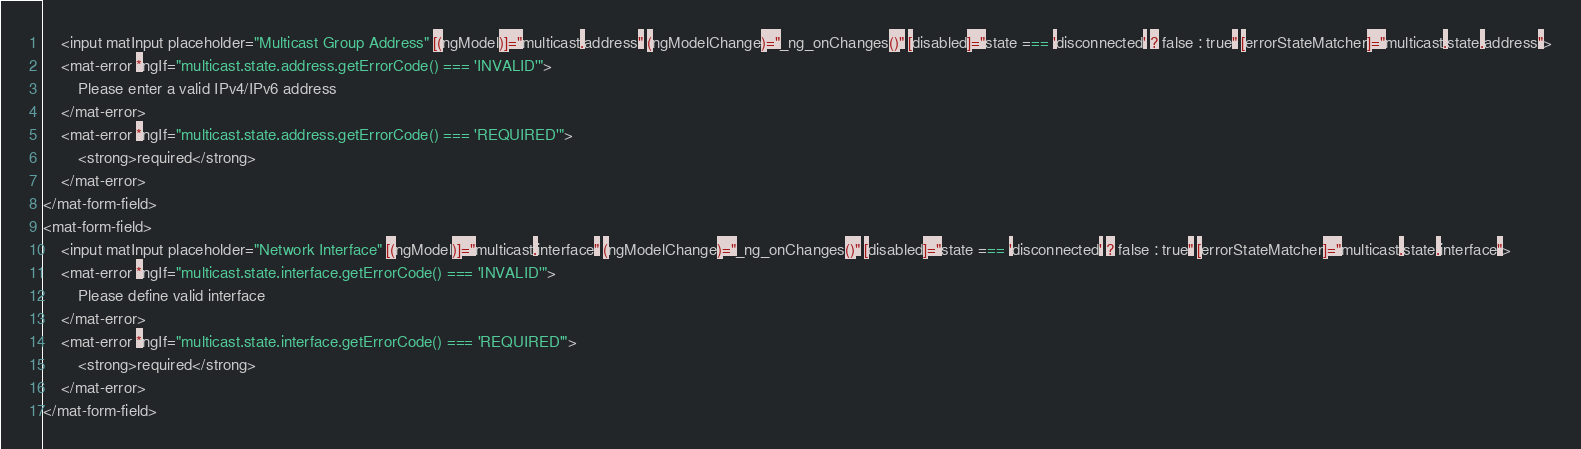<code> <loc_0><loc_0><loc_500><loc_500><_HTML_>    <input matInput placeholder="Multicast Group Address" [(ngModel)]="multicast.address" (ngModelChange)="_ng_onChanges()" [disabled]="state === 'disconnected' ? false : true" [errorStateMatcher]="multicast.state.address">
    <mat-error *ngIf="multicast.state.address.getErrorCode() === 'INVALID'">
        Please enter a valid IPv4/IPv6 address
    </mat-error>
    <mat-error *ngIf="multicast.state.address.getErrorCode() === 'REQUIRED'">
        <strong>required</strong>
    </mat-error>
</mat-form-field>
<mat-form-field>
    <input matInput placeholder="Network Interface" [(ngModel)]="multicast.interface" (ngModelChange)="_ng_onChanges()" [disabled]="state === 'disconnected' ? false : true" [errorStateMatcher]="multicast.state.interface">
    <mat-error *ngIf="multicast.state.interface.getErrorCode() === 'INVALID'">
        Please define valid interface
    </mat-error>
    <mat-error *ngIf="multicast.state.interface.getErrorCode() === 'REQUIRED'">
        <strong>required</strong>
    </mat-error>
</mat-form-field>

</code> 